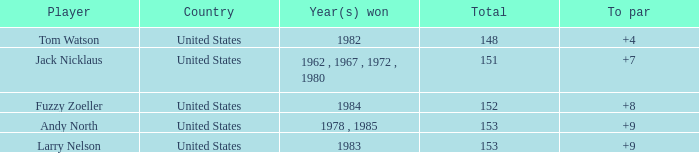What is the sum for the player with a to par of 4? 1.0. 